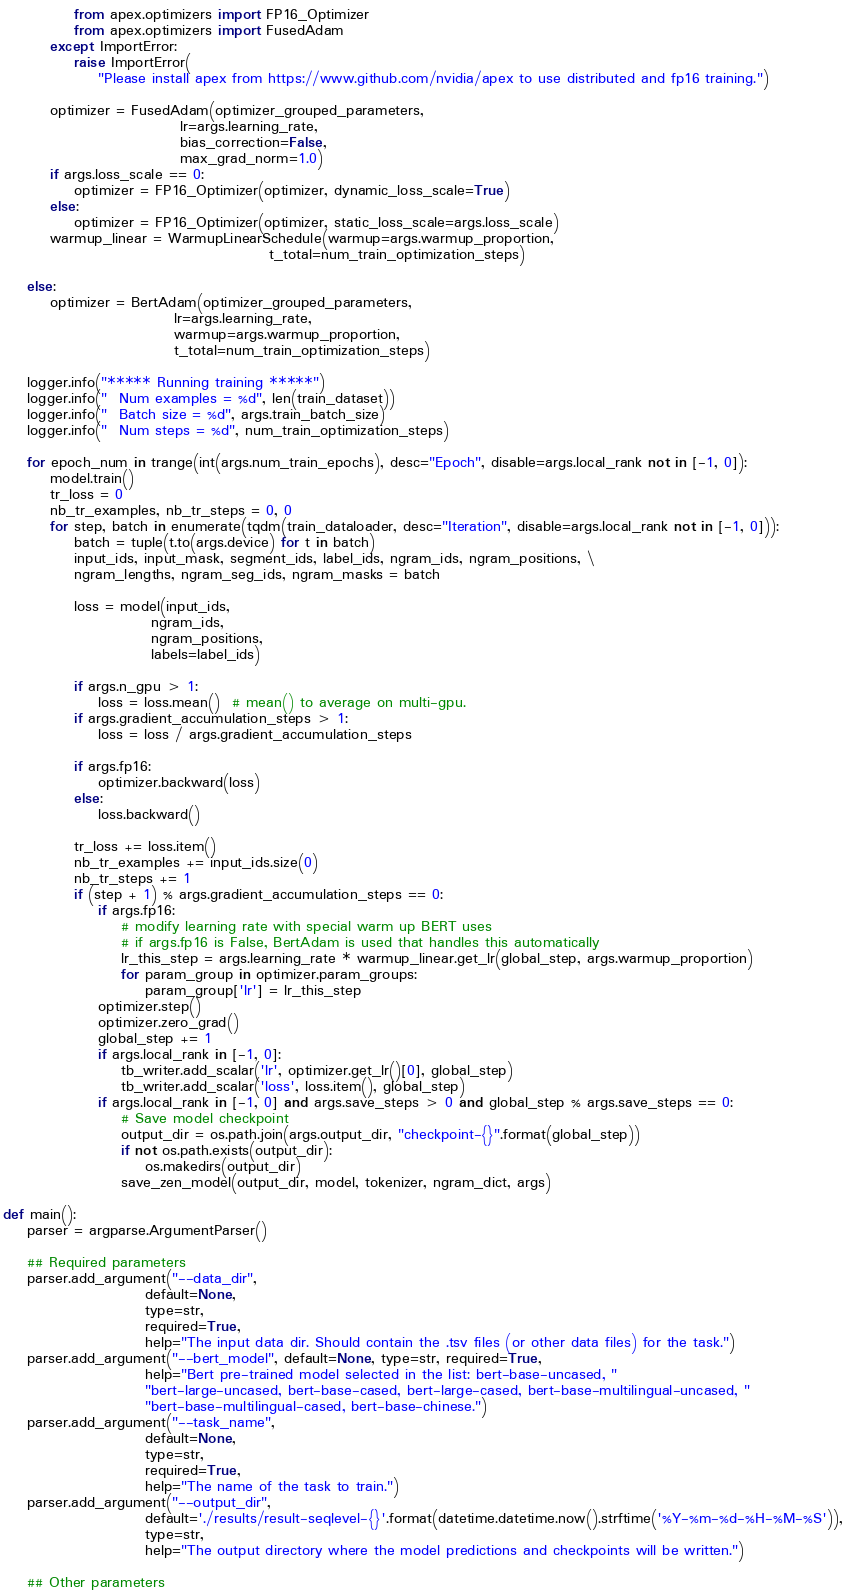Convert code to text. <code><loc_0><loc_0><loc_500><loc_500><_Python_>            from apex.optimizers import FP16_Optimizer
            from apex.optimizers import FusedAdam
        except ImportError:
            raise ImportError(
                "Please install apex from https://www.github.com/nvidia/apex to use distributed and fp16 training.")

        optimizer = FusedAdam(optimizer_grouped_parameters,
                              lr=args.learning_rate,
                              bias_correction=False,
                              max_grad_norm=1.0)
        if args.loss_scale == 0:
            optimizer = FP16_Optimizer(optimizer, dynamic_loss_scale=True)
        else:
            optimizer = FP16_Optimizer(optimizer, static_loss_scale=args.loss_scale)
        warmup_linear = WarmupLinearSchedule(warmup=args.warmup_proportion,
                                             t_total=num_train_optimization_steps)

    else:
        optimizer = BertAdam(optimizer_grouped_parameters,
                             lr=args.learning_rate,
                             warmup=args.warmup_proportion,
                             t_total=num_train_optimization_steps)

    logger.info("***** Running training *****")
    logger.info("  Num examples = %d", len(train_dataset))
    logger.info("  Batch size = %d", args.train_batch_size)
    logger.info("  Num steps = %d", num_train_optimization_steps)

    for epoch_num in trange(int(args.num_train_epochs), desc="Epoch", disable=args.local_rank not in [-1, 0]):
        model.train()
        tr_loss = 0
        nb_tr_examples, nb_tr_steps = 0, 0
        for step, batch in enumerate(tqdm(train_dataloader, desc="Iteration", disable=args.local_rank not in [-1, 0])):
            batch = tuple(t.to(args.device) for t in batch)
            input_ids, input_mask, segment_ids, label_ids, ngram_ids, ngram_positions, \
            ngram_lengths, ngram_seg_ids, ngram_masks = batch

            loss = model(input_ids,
                         ngram_ids,
                         ngram_positions,
                         labels=label_ids)

            if args.n_gpu > 1:
                loss = loss.mean()  # mean() to average on multi-gpu.
            if args.gradient_accumulation_steps > 1:
                loss = loss / args.gradient_accumulation_steps

            if args.fp16:
                optimizer.backward(loss)
            else:
                loss.backward()

            tr_loss += loss.item()
            nb_tr_examples += input_ids.size(0)
            nb_tr_steps += 1
            if (step + 1) % args.gradient_accumulation_steps == 0:
                if args.fp16:
                    # modify learning rate with special warm up BERT uses
                    # if args.fp16 is False, BertAdam is used that handles this automatically
                    lr_this_step = args.learning_rate * warmup_linear.get_lr(global_step, args.warmup_proportion)
                    for param_group in optimizer.param_groups:
                        param_group['lr'] = lr_this_step
                optimizer.step()
                optimizer.zero_grad()
                global_step += 1
                if args.local_rank in [-1, 0]:
                    tb_writer.add_scalar('lr', optimizer.get_lr()[0], global_step)
                    tb_writer.add_scalar('loss', loss.item(), global_step)
                if args.local_rank in [-1, 0] and args.save_steps > 0 and global_step % args.save_steps == 0:
                    # Save model checkpoint
                    output_dir = os.path.join(args.output_dir, "checkpoint-{}".format(global_step))
                    if not os.path.exists(output_dir):
                        os.makedirs(output_dir)
                    save_zen_model(output_dir, model, tokenizer, ngram_dict, args)

def main():
    parser = argparse.ArgumentParser()

    ## Required parameters
    parser.add_argument("--data_dir",
                        default=None,
                        type=str,
                        required=True,
                        help="The input data dir. Should contain the .tsv files (or other data files) for the task.")
    parser.add_argument("--bert_model", default=None, type=str, required=True,
                        help="Bert pre-trained model selected in the list: bert-base-uncased, "
                        "bert-large-uncased, bert-base-cased, bert-large-cased, bert-base-multilingual-uncased, "
                        "bert-base-multilingual-cased, bert-base-chinese.")
    parser.add_argument("--task_name",
                        default=None,
                        type=str,
                        required=True,
                        help="The name of the task to train.")
    parser.add_argument("--output_dir",
                        default='./results/result-seqlevel-{}'.format(datetime.datetime.now().strftime('%Y-%m-%d-%H-%M-%S')),
                        type=str,
                        help="The output directory where the model predictions and checkpoints will be written.")

    ## Other parameters</code> 